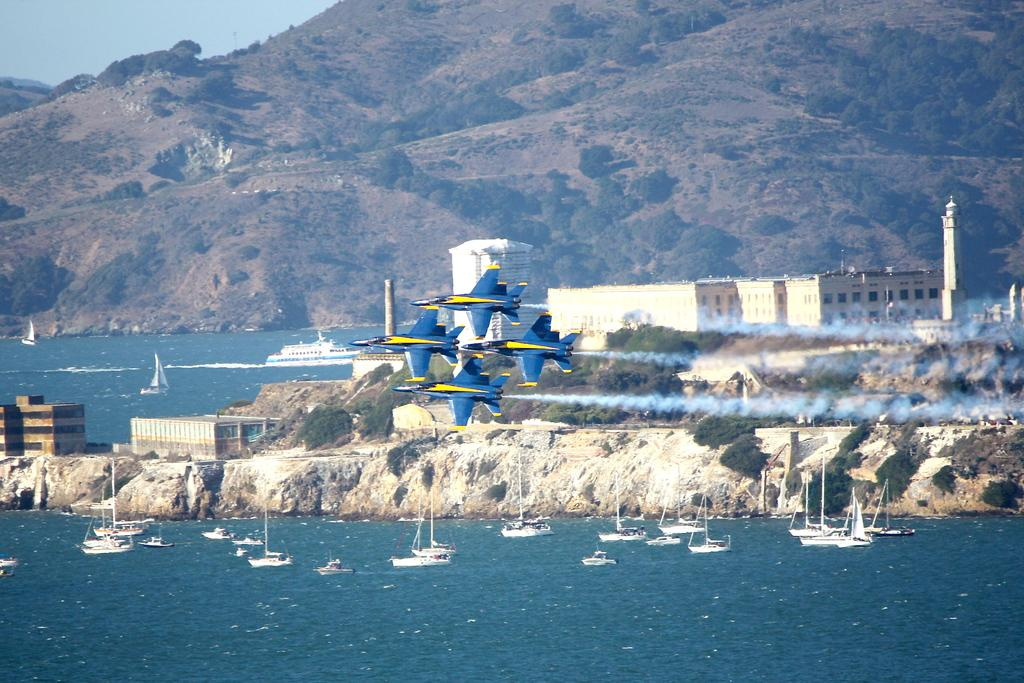What type of vehicles are present in the image? There are four fighter planes in the image. What are the fighter planes doing in the image? The fighter planes are moving simultaneously. What can be seen in the background of the image? There are beautiful mountains and ships near the sea in the background of the image. What type of wrench is being used by the fighter planes in the image? There is no wrench present in the image; it features four fighter planes moving simultaneously. How does the self-driving technology affect the fighter planes' movements in the image? The image does not mention or depict any self-driving technology, so it cannot be determined how it would affect the fighter planes' movements. 